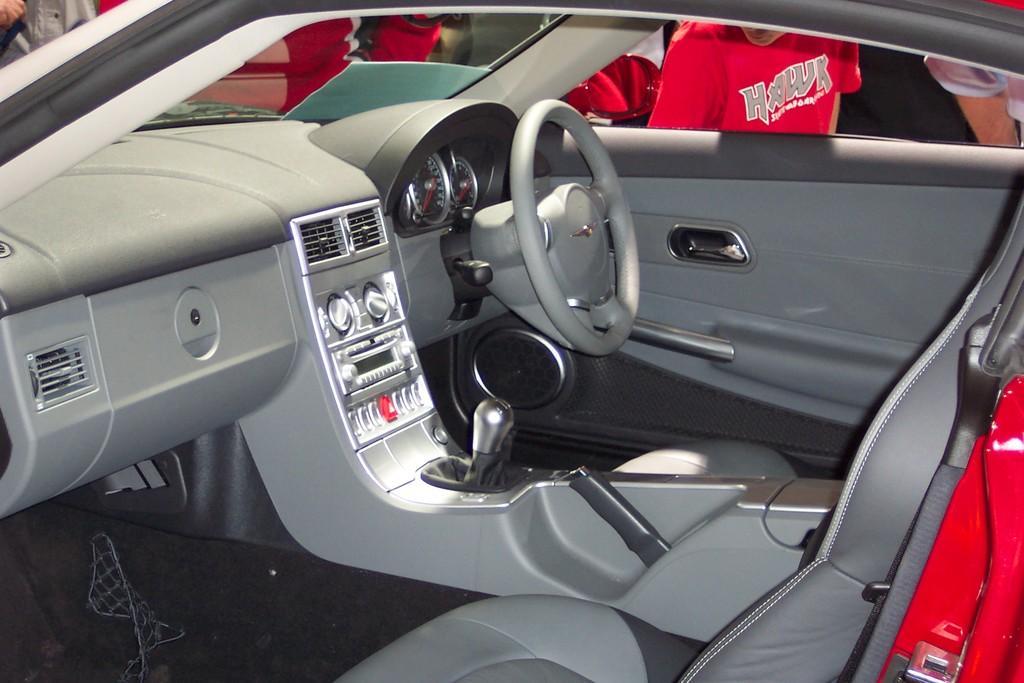Could you give a brief overview of what you see in this image? In the foreground of this picture we can see the seat, steering wheel, door, window and speedometer and some other parts of the car. In the background we can see the group of persons and some other objects. 